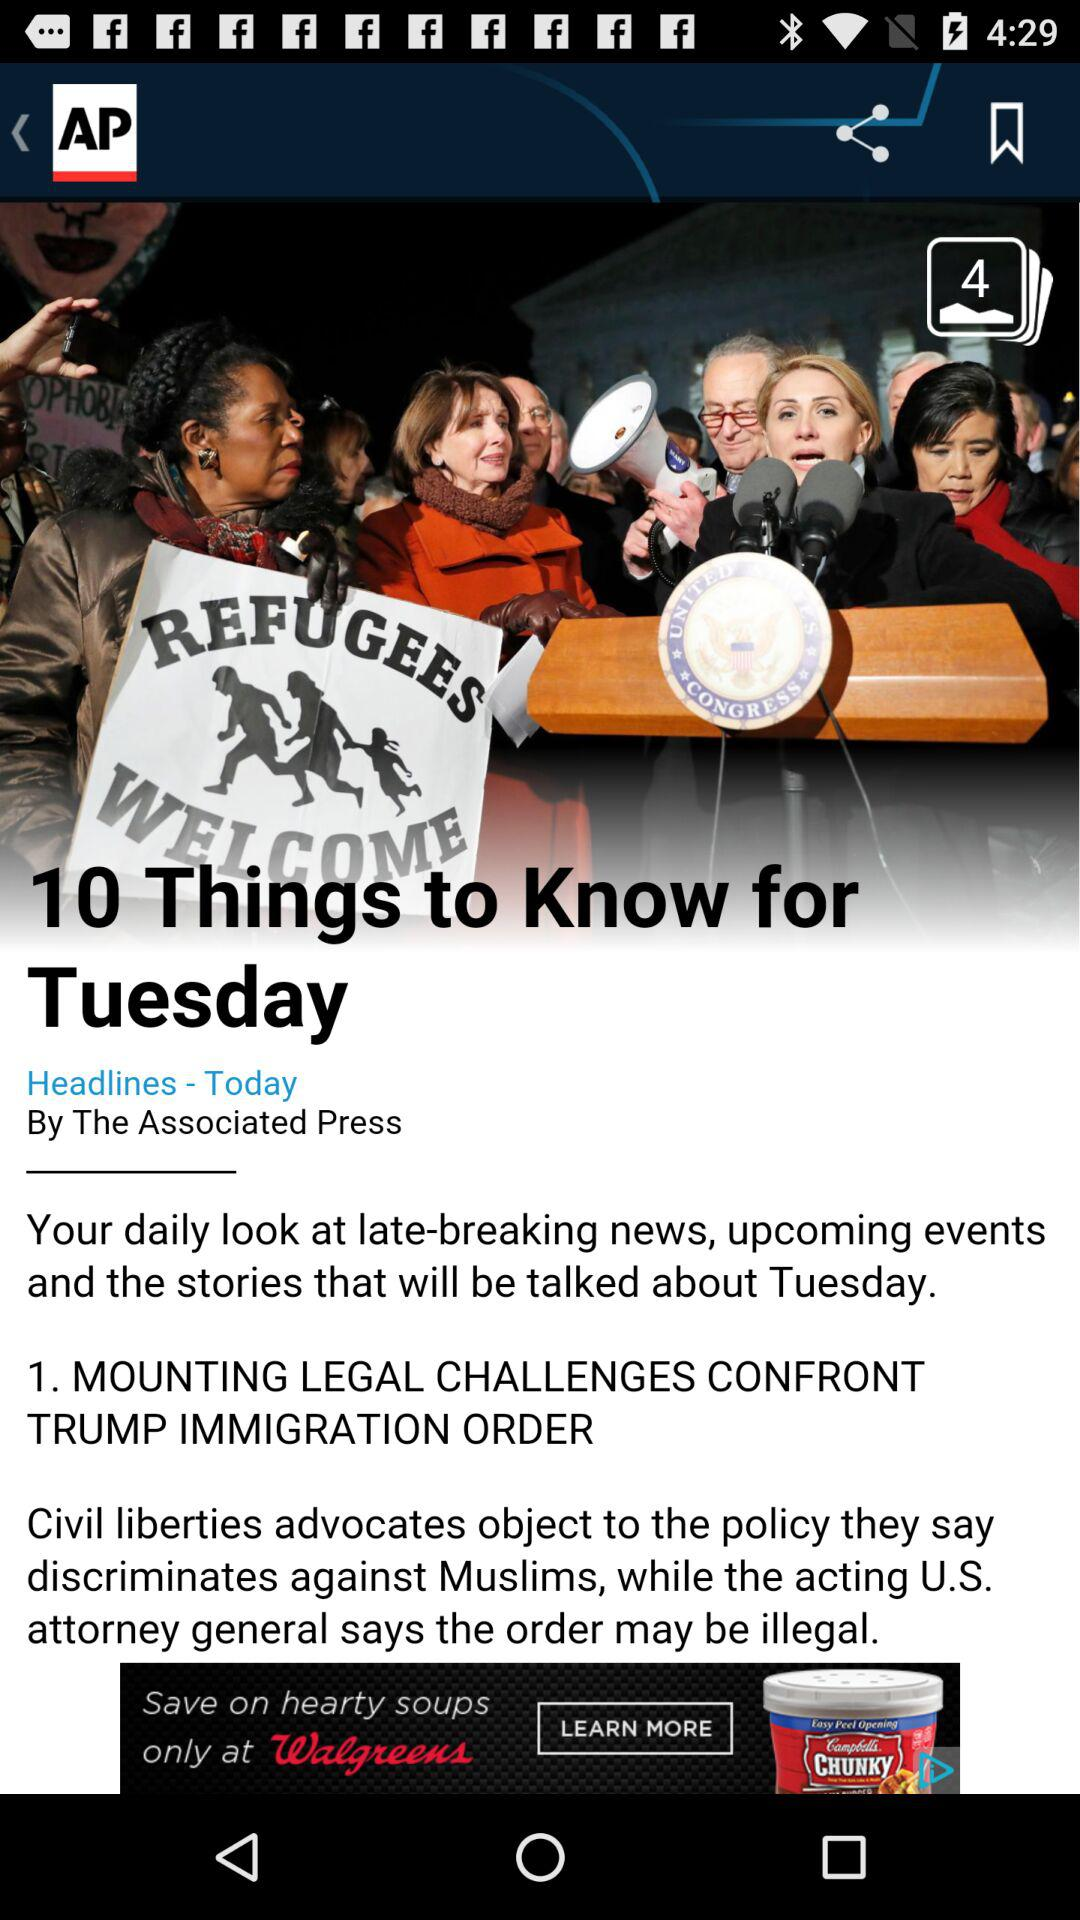Who is the author of the article? The author of the article is "The Associated Press". 